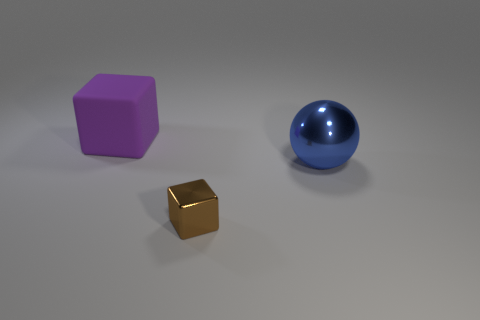Add 3 large yellow shiny objects. How many objects exist? 6 Subtract all cubes. How many objects are left? 1 Subtract all large matte blocks. Subtract all metal blocks. How many objects are left? 1 Add 1 blue balls. How many blue balls are left? 2 Add 3 tiny gray metal spheres. How many tiny gray metal spheres exist? 3 Subtract 0 yellow balls. How many objects are left? 3 